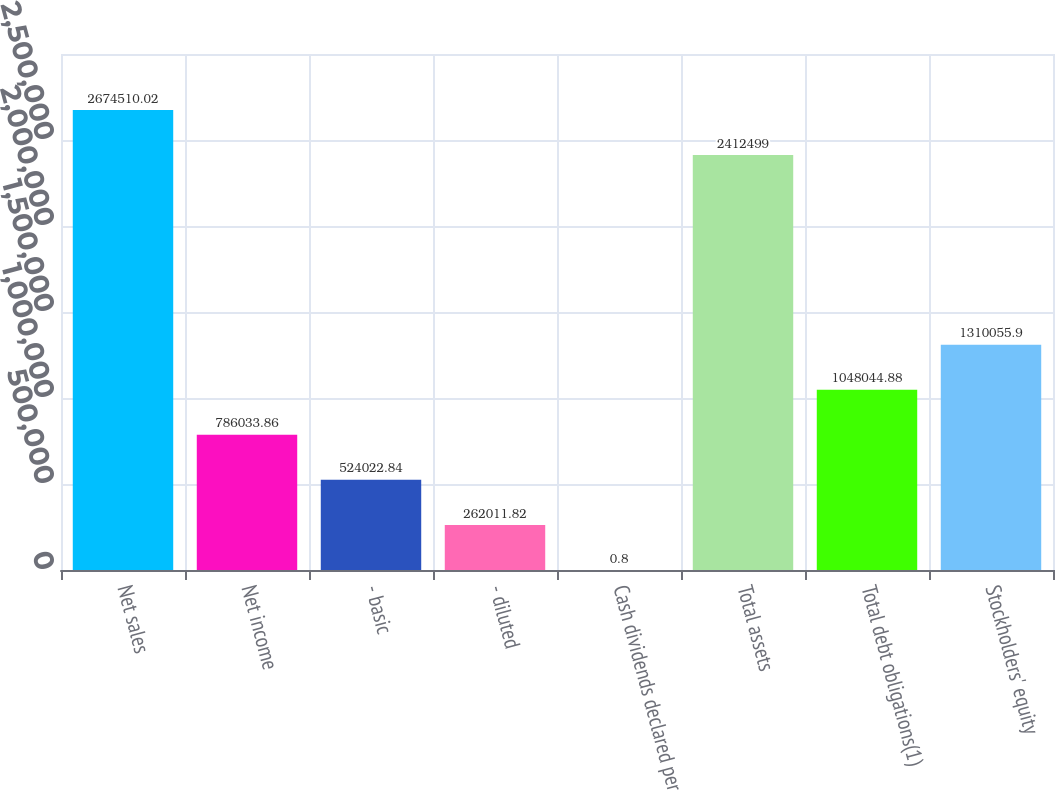Convert chart to OTSL. <chart><loc_0><loc_0><loc_500><loc_500><bar_chart><fcel>Net sales<fcel>Net income<fcel>- basic<fcel>- diluted<fcel>Cash dividends declared per<fcel>Total assets<fcel>Total debt obligations(1)<fcel>Stockholders' equity<nl><fcel>2.67451e+06<fcel>786034<fcel>524023<fcel>262012<fcel>0.8<fcel>2.4125e+06<fcel>1.04804e+06<fcel>1.31006e+06<nl></chart> 